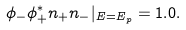Convert formula to latex. <formula><loc_0><loc_0><loc_500><loc_500>\phi _ { - } \phi _ { + } ^ { \ast } n _ { + } n _ { - } | _ { E = E _ { p } } = 1 . 0 .</formula> 